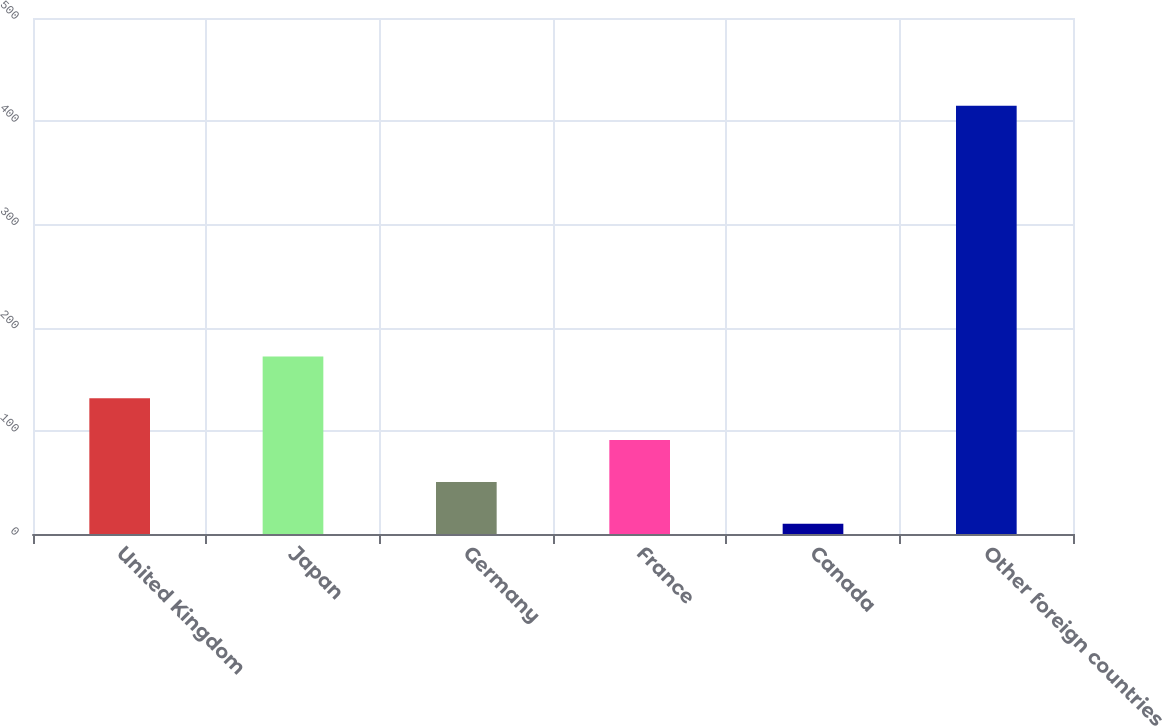Convert chart to OTSL. <chart><loc_0><loc_0><loc_500><loc_500><bar_chart><fcel>United Kingdom<fcel>Japan<fcel>Germany<fcel>France<fcel>Canada<fcel>Other foreign countries<nl><fcel>131.5<fcel>172<fcel>50.5<fcel>91<fcel>10<fcel>415<nl></chart> 